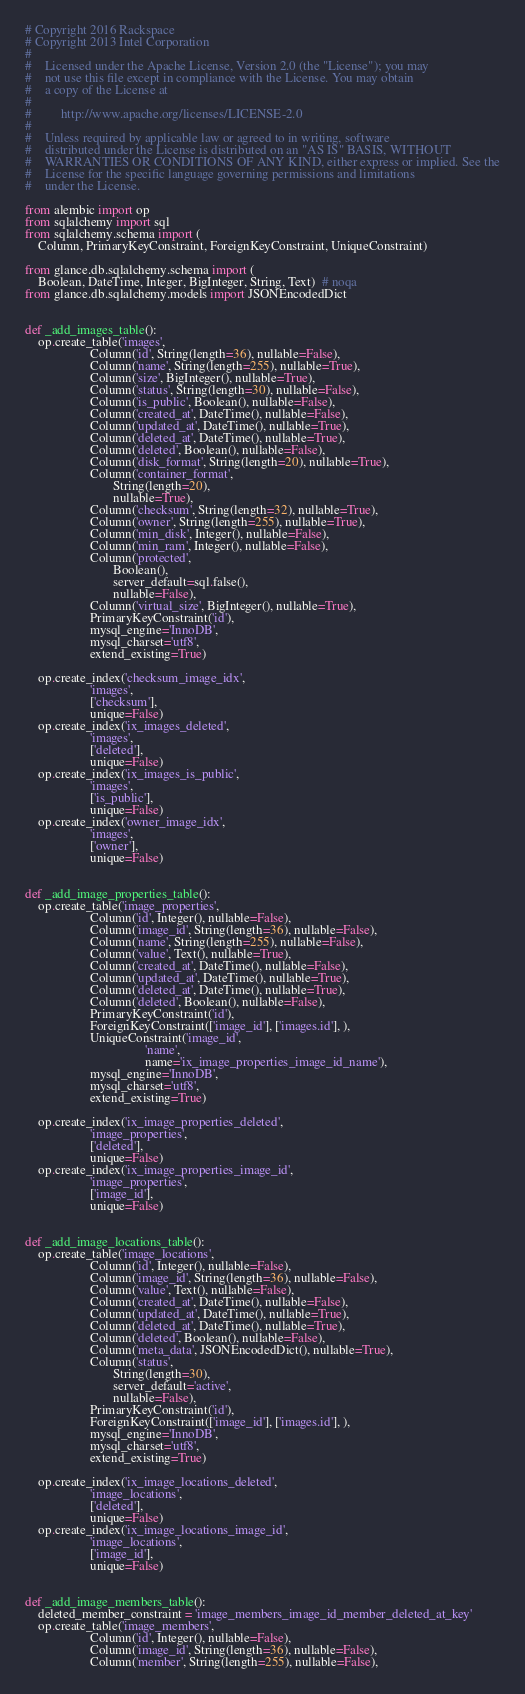Convert code to text. <code><loc_0><loc_0><loc_500><loc_500><_Python_># Copyright 2016 Rackspace
# Copyright 2013 Intel Corporation
#
#    Licensed under the Apache License, Version 2.0 (the "License"); you may
#    not use this file except in compliance with the License. You may obtain
#    a copy of the License at
#
#         http://www.apache.org/licenses/LICENSE-2.0
#
#    Unless required by applicable law or agreed to in writing, software
#    distributed under the License is distributed on an "AS IS" BASIS, WITHOUT
#    WARRANTIES OR CONDITIONS OF ANY KIND, either express or implied. See the
#    License for the specific language governing permissions and limitations
#    under the License.

from alembic import op
from sqlalchemy import sql
from sqlalchemy.schema import (
    Column, PrimaryKeyConstraint, ForeignKeyConstraint, UniqueConstraint)

from glance.db.sqlalchemy.schema import (
    Boolean, DateTime, Integer, BigInteger, String, Text)  # noqa
from glance.db.sqlalchemy.models import JSONEncodedDict


def _add_images_table():
    op.create_table('images',
                    Column('id', String(length=36), nullable=False),
                    Column('name', String(length=255), nullable=True),
                    Column('size', BigInteger(), nullable=True),
                    Column('status', String(length=30), nullable=False),
                    Column('is_public', Boolean(), nullable=False),
                    Column('created_at', DateTime(), nullable=False),
                    Column('updated_at', DateTime(), nullable=True),
                    Column('deleted_at', DateTime(), nullable=True),
                    Column('deleted', Boolean(), nullable=False),
                    Column('disk_format', String(length=20), nullable=True),
                    Column('container_format',
                           String(length=20),
                           nullable=True),
                    Column('checksum', String(length=32), nullable=True),
                    Column('owner', String(length=255), nullable=True),
                    Column('min_disk', Integer(), nullable=False),
                    Column('min_ram', Integer(), nullable=False),
                    Column('protected',
                           Boolean(),
                           server_default=sql.false(),
                           nullable=False),
                    Column('virtual_size', BigInteger(), nullable=True),
                    PrimaryKeyConstraint('id'),
                    mysql_engine='InnoDB',
                    mysql_charset='utf8',
                    extend_existing=True)

    op.create_index('checksum_image_idx',
                    'images',
                    ['checksum'],
                    unique=False)
    op.create_index('ix_images_deleted',
                    'images',
                    ['deleted'],
                    unique=False)
    op.create_index('ix_images_is_public',
                    'images',
                    ['is_public'],
                    unique=False)
    op.create_index('owner_image_idx',
                    'images',
                    ['owner'],
                    unique=False)


def _add_image_properties_table():
    op.create_table('image_properties',
                    Column('id', Integer(), nullable=False),
                    Column('image_id', String(length=36), nullable=False),
                    Column('name', String(length=255), nullable=False),
                    Column('value', Text(), nullable=True),
                    Column('created_at', DateTime(), nullable=False),
                    Column('updated_at', DateTime(), nullable=True),
                    Column('deleted_at', DateTime(), nullable=True),
                    Column('deleted', Boolean(), nullable=False),
                    PrimaryKeyConstraint('id'),
                    ForeignKeyConstraint(['image_id'], ['images.id'], ),
                    UniqueConstraint('image_id',
                                     'name',
                                     name='ix_image_properties_image_id_name'),
                    mysql_engine='InnoDB',
                    mysql_charset='utf8',
                    extend_existing=True)

    op.create_index('ix_image_properties_deleted',
                    'image_properties',
                    ['deleted'],
                    unique=False)
    op.create_index('ix_image_properties_image_id',
                    'image_properties',
                    ['image_id'],
                    unique=False)


def _add_image_locations_table():
    op.create_table('image_locations',
                    Column('id', Integer(), nullable=False),
                    Column('image_id', String(length=36), nullable=False),
                    Column('value', Text(), nullable=False),
                    Column('created_at', DateTime(), nullable=False),
                    Column('updated_at', DateTime(), nullable=True),
                    Column('deleted_at', DateTime(), nullable=True),
                    Column('deleted', Boolean(), nullable=False),
                    Column('meta_data', JSONEncodedDict(), nullable=True),
                    Column('status',
                           String(length=30),
                           server_default='active',
                           nullable=False),
                    PrimaryKeyConstraint('id'),
                    ForeignKeyConstraint(['image_id'], ['images.id'], ),
                    mysql_engine='InnoDB',
                    mysql_charset='utf8',
                    extend_existing=True)

    op.create_index('ix_image_locations_deleted',
                    'image_locations',
                    ['deleted'],
                    unique=False)
    op.create_index('ix_image_locations_image_id',
                    'image_locations',
                    ['image_id'],
                    unique=False)


def _add_image_members_table():
    deleted_member_constraint = 'image_members_image_id_member_deleted_at_key'
    op.create_table('image_members',
                    Column('id', Integer(), nullable=False),
                    Column('image_id', String(length=36), nullable=False),
                    Column('member', String(length=255), nullable=False),</code> 